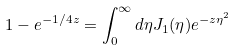<formula> <loc_0><loc_0><loc_500><loc_500>1 - e ^ { - 1 / 4 z } = \int _ { 0 } ^ { \infty } d \eta J _ { 1 } ( \eta ) e ^ { - z \eta ^ { 2 } }</formula> 